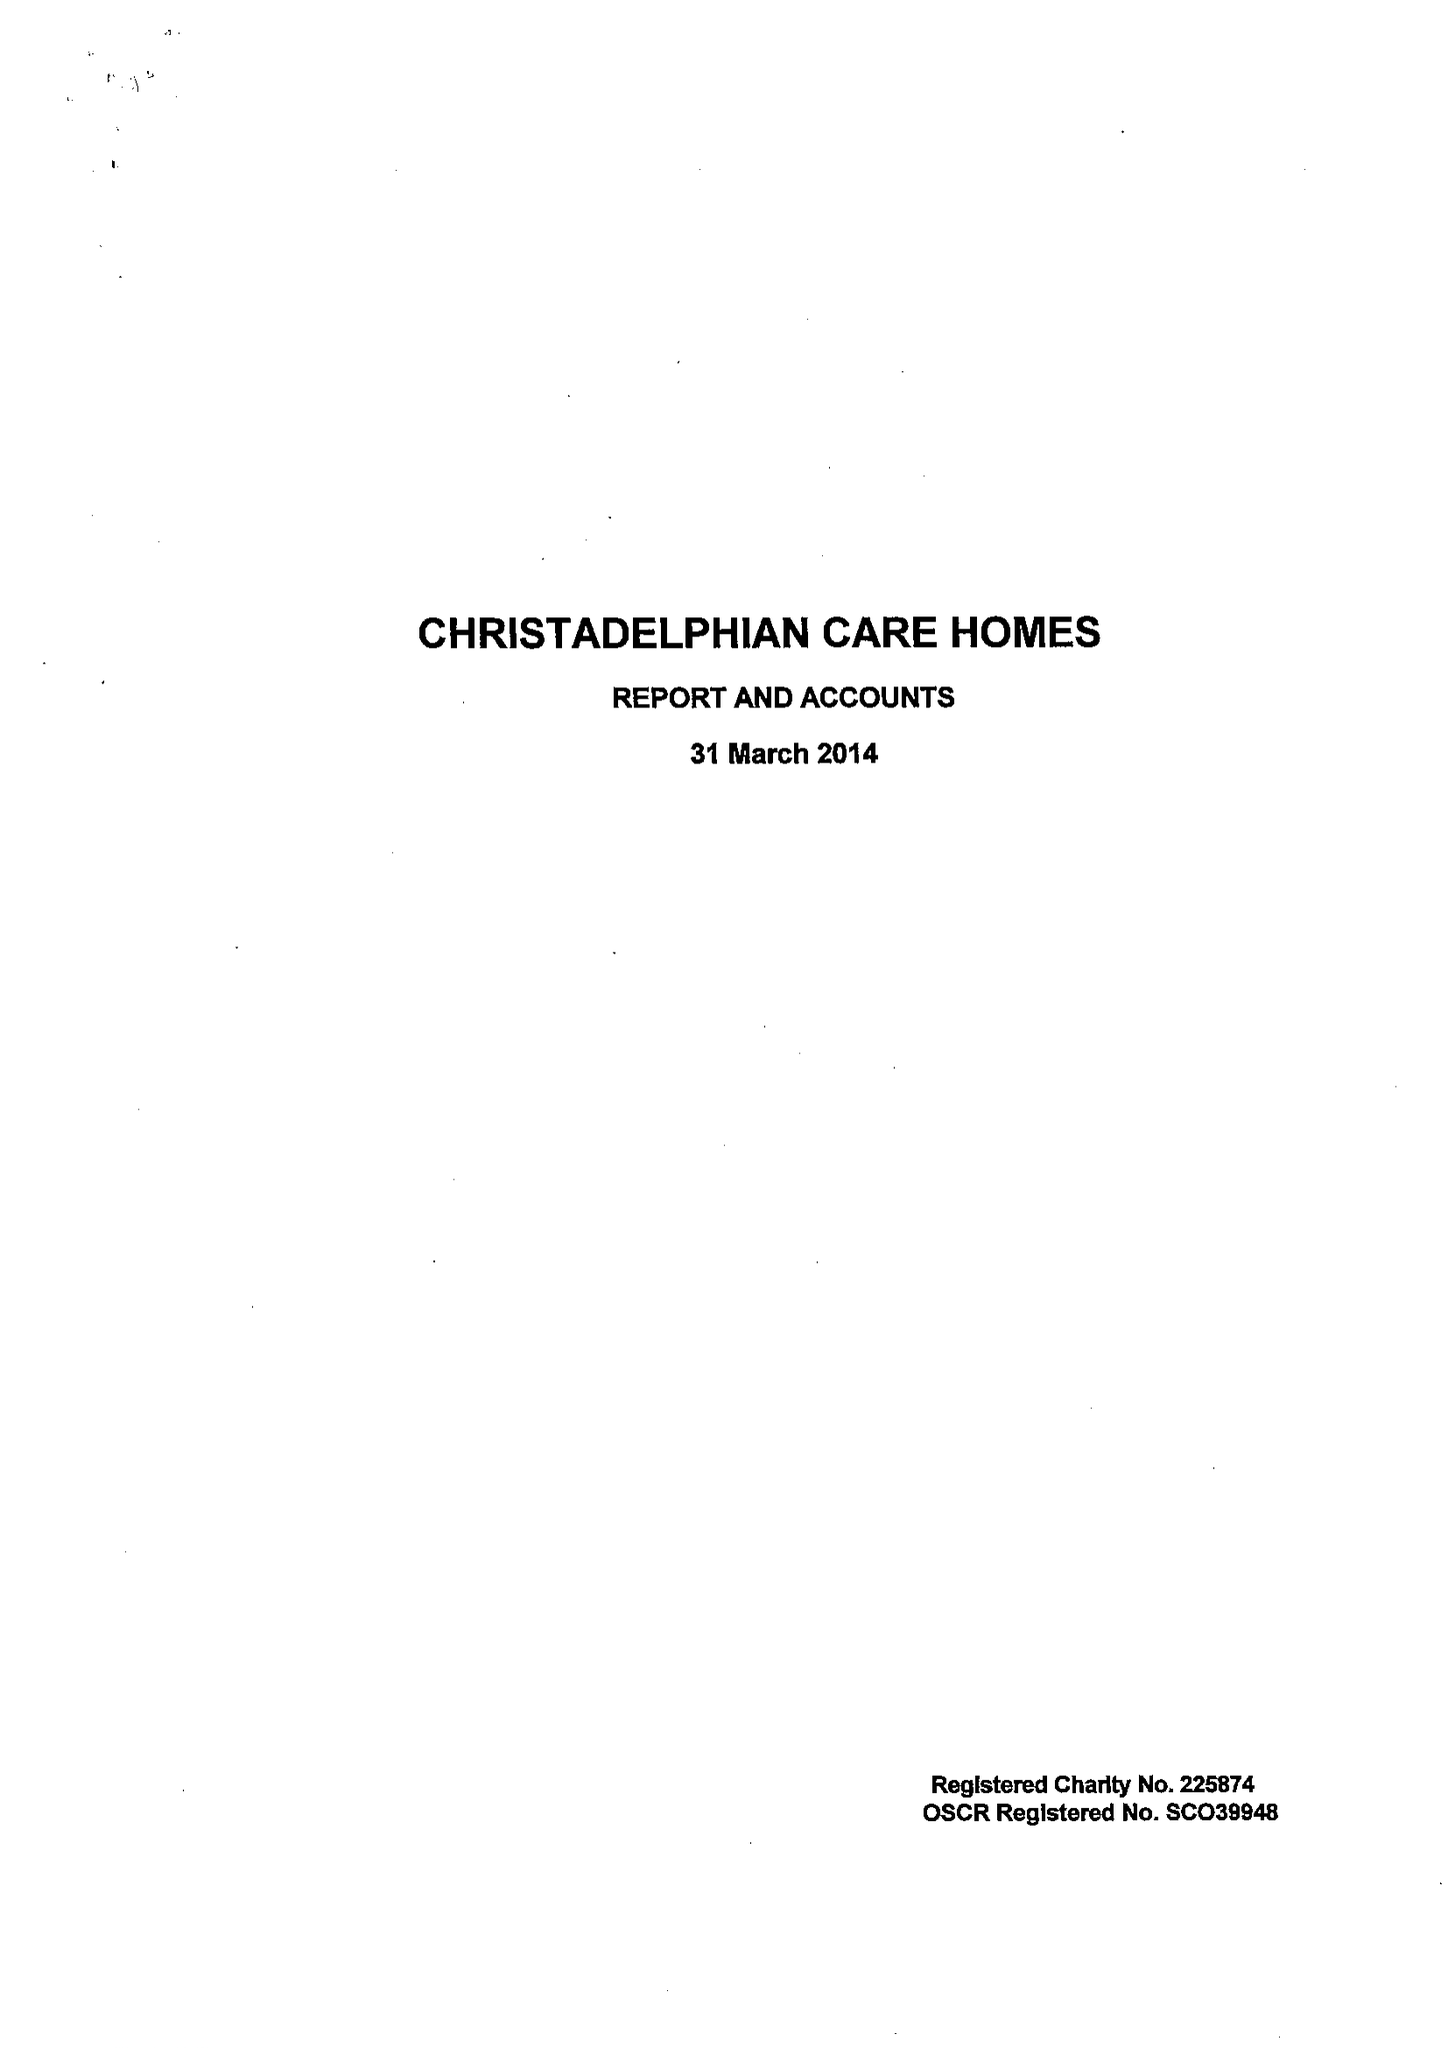What is the value for the charity_name?
Answer the question using a single word or phrase. Christadelphian Care Homes 